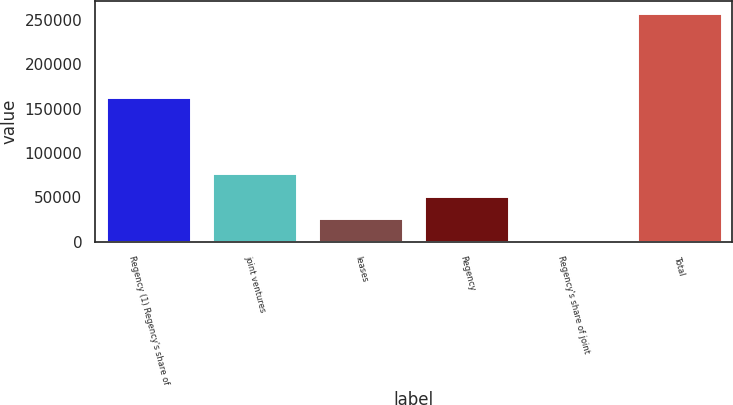<chart> <loc_0><loc_0><loc_500><loc_500><bar_chart><fcel>Regency (1) Regency's share of<fcel>joint ventures<fcel>leases<fcel>Regency<fcel>Regency's share of joint<fcel>Total<nl><fcel>163223<fcel>77685.3<fcel>26157.1<fcel>51921.2<fcel>393<fcel>258034<nl></chart> 